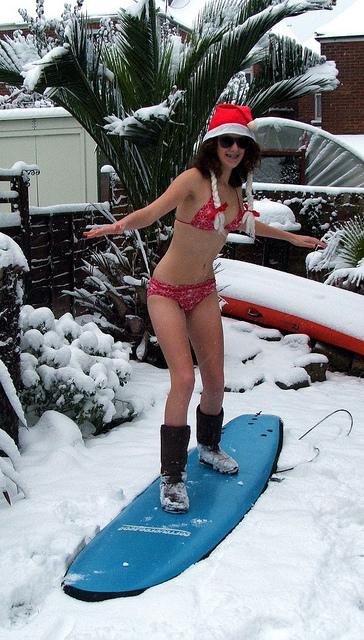Why would you suspect this was taken around Christmas?
Concise answer only. Santa hat. Is the woman surfer?
Be succinct. No. What is wrong with this picture?
Concise answer only. Clothing. 